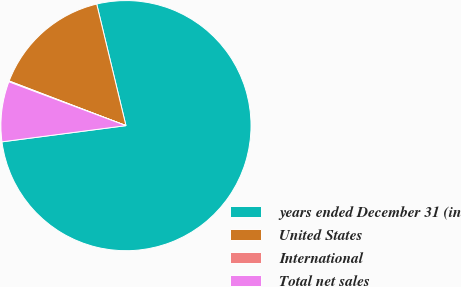<chart> <loc_0><loc_0><loc_500><loc_500><pie_chart><fcel>years ended December 31 (in<fcel>United States<fcel>International<fcel>Total net sales<nl><fcel>76.69%<fcel>15.43%<fcel>0.11%<fcel>7.77%<nl></chart> 